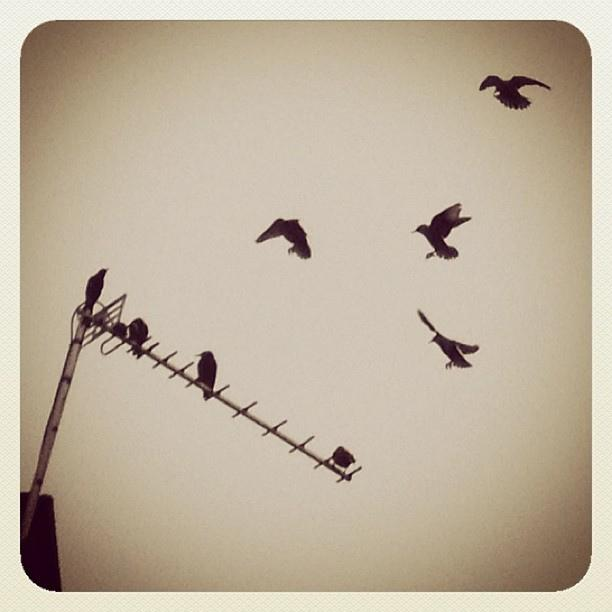Why do the birds seek high up places? Please explain your reasoning. safety. The birds feel safe high up in the air. 